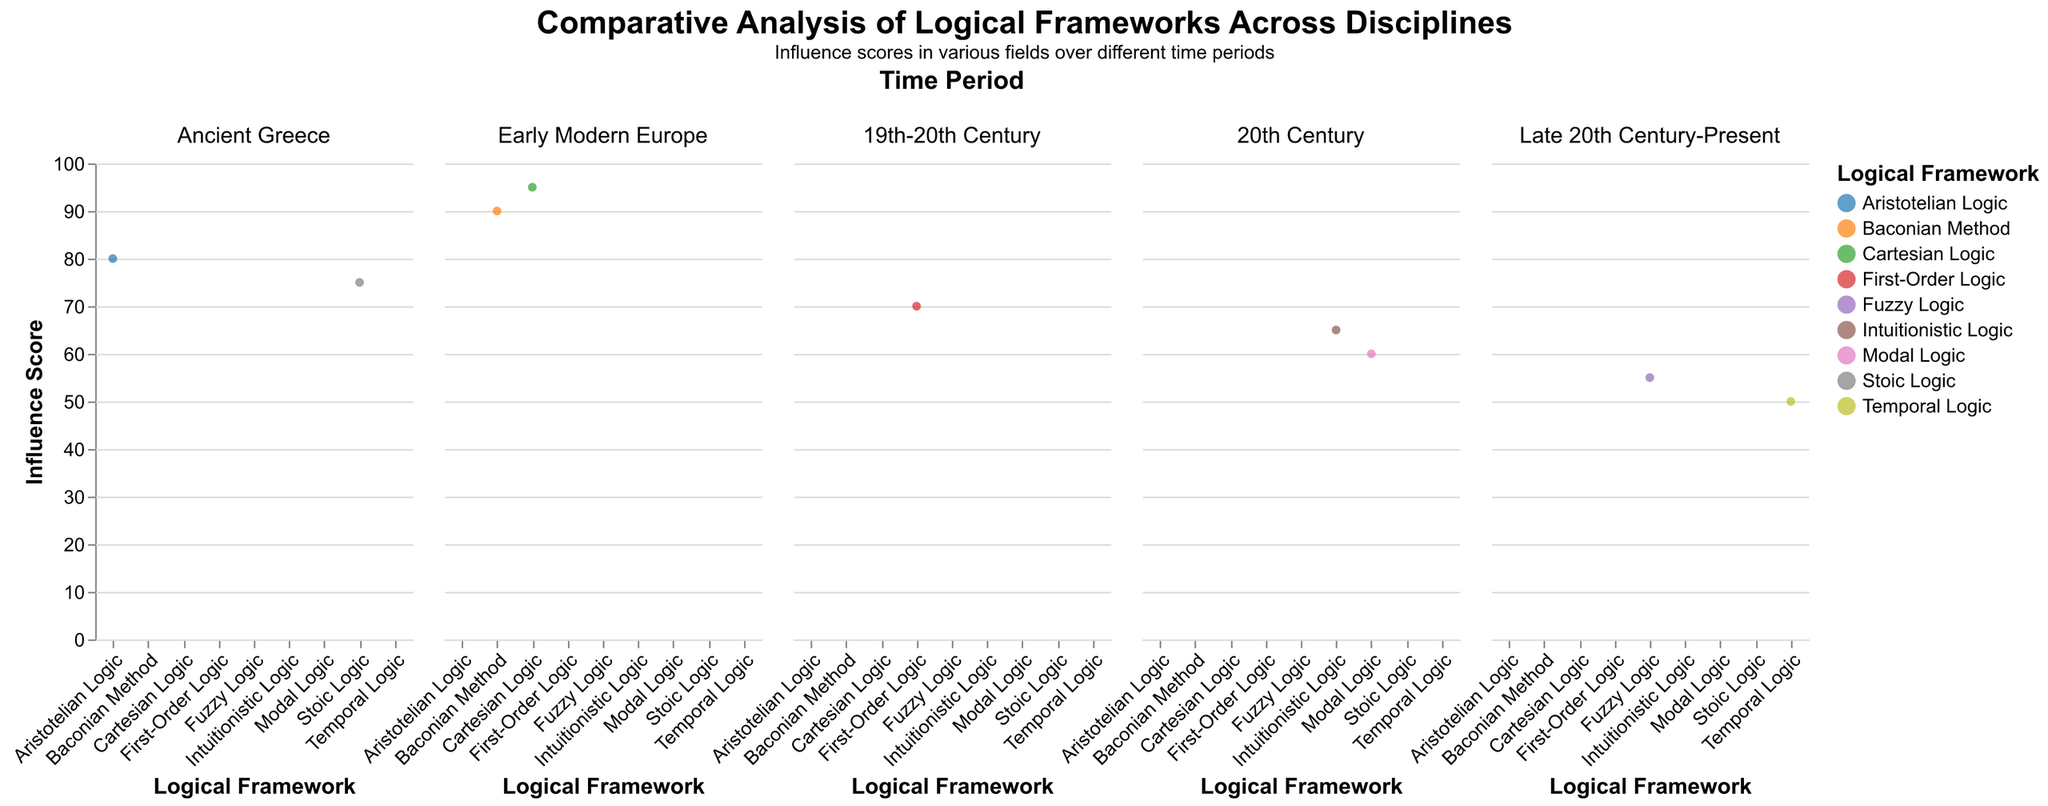What is the total influence score for Philosophy in the Ancient Greece time period? Add the Philosophy scores for Aristotelian Logic and Stoic Logic: 80 + 75 = 155
Answer: 155 In the 20th Century, which logical framework has the highest influence in Computer Science? Compare the influence scores of Intuitionistic Logic and Modal Logic in Computer Science: 35 and 45 respectively. 45 is higher.
Answer: Modal Logic How does the influence of Fuzzy Logic in Mathematics compare to that in Law? Refer to the influence scores for Fuzzy Logic in Mathematics and Law: 40 and 35 respectively. Mathematics has a higher score.
Answer: Mathematics Which logical framework in the Early Modern Europe period has a higher influence in Philosophy, Baconian Method or Cartesian Logic? Compare the Philosophy scores for Baconian Method and Cartesian Logic: 90 and 95 respectively. 95 is higher.
Answer: Cartesian Logic What is the average influence score of Computer Science across all time periods? Add the Computer Science scores for all frameworks: 5 + 5 + 10 + 20 + 40 + 35 + 45 + 60 + 55 = 275. Divide by the number of frameworks, 9. 275/9 ≈ 30.6
Answer: 30.6 Across all time periods, which discipline consistently has the lowest influence scores? Review the scores for all disciplines and frameworks. Linguistics often has the lowest scores.
Answer: Linguistics What trend do you notice in the influence of Philosophy from Ancient Greece to the Late 20th Century-Present? Trace the influence scores for Philosophy across the time periods: 80, 75, 90, 95, 70, 65, 60, 50, 55. There is a general decrease over time.
Answer: Decreasing trend In the Late 20th Century-Present period, which logical framework has a higher influence in Linguistics, Temporal Logic or Fuzzy Logic? Compare the Linguistics scores for Temporal Logic and Fuzzy Logic: 25 and 30 respectively. 30 is higher.
Answer: Fuzzy Logic 